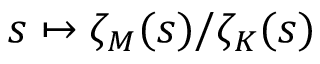Convert formula to latex. <formula><loc_0><loc_0><loc_500><loc_500>s \mapsto \zeta _ { M } ( s ) / \zeta _ { K } ( s )</formula> 